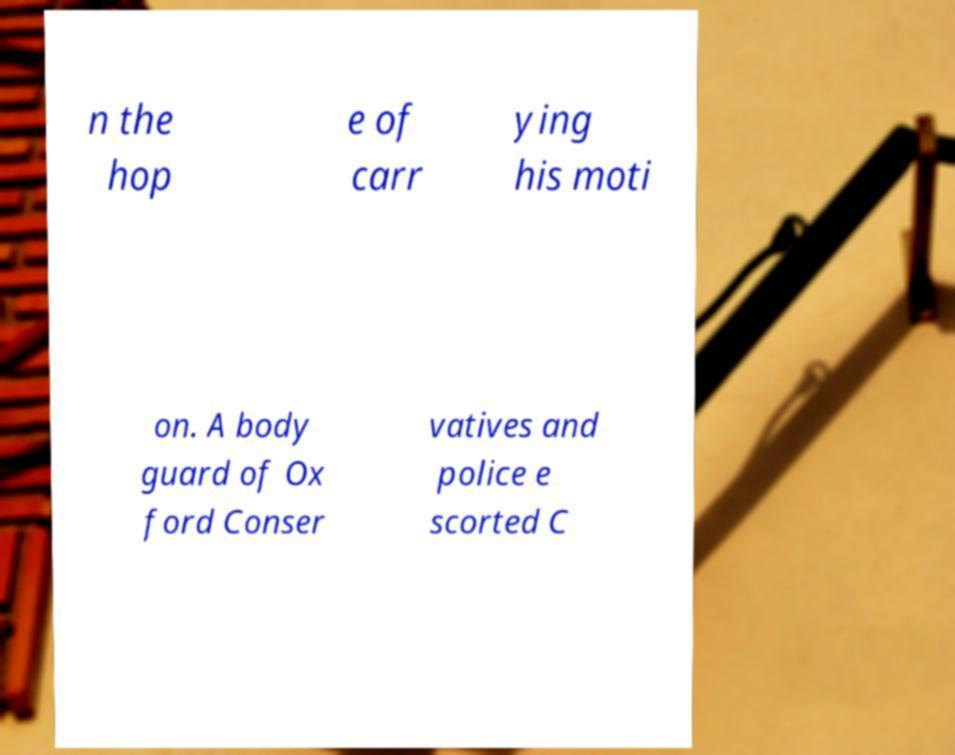Could you extract and type out the text from this image? n the hop e of carr ying his moti on. A body guard of Ox ford Conser vatives and police e scorted C 